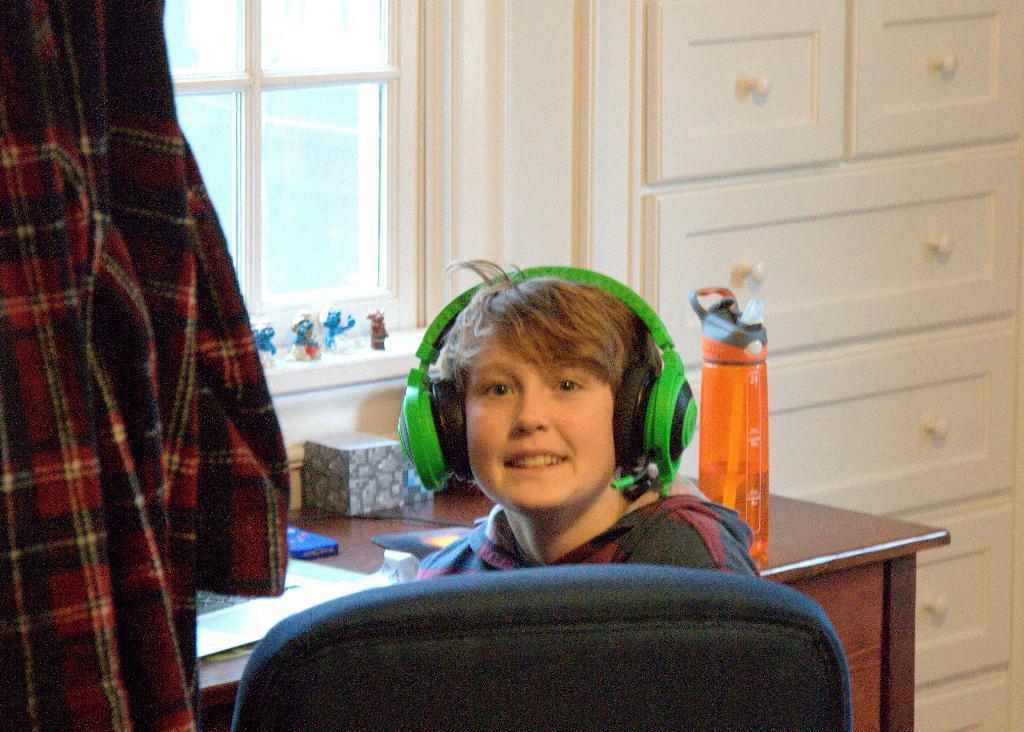Could you give a brief overview of what you see in this image? In this image there is a boy sitting on the chair, wearing headphones. In the top-left there is a glass window. In the right, there is a cupboard with drawers. In the bottom of the image, there is a table with bottle, gift box and some papers are kept. In the left of, there is a full sleeve shirt hanging. On the window side there are toys kept. 